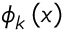Convert formula to latex. <formula><loc_0><loc_0><loc_500><loc_500>\phi _ { k } \left ( x \right )</formula> 